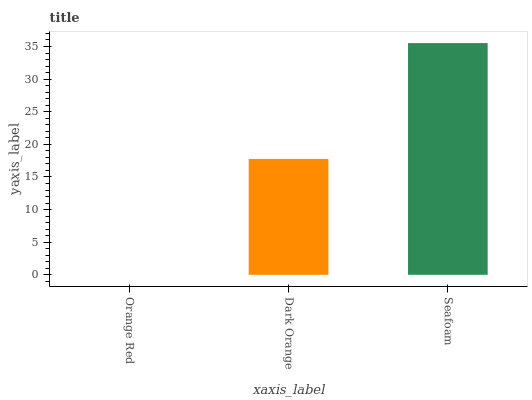Is Dark Orange the minimum?
Answer yes or no. No. Is Dark Orange the maximum?
Answer yes or no. No. Is Dark Orange greater than Orange Red?
Answer yes or no. Yes. Is Orange Red less than Dark Orange?
Answer yes or no. Yes. Is Orange Red greater than Dark Orange?
Answer yes or no. No. Is Dark Orange less than Orange Red?
Answer yes or no. No. Is Dark Orange the high median?
Answer yes or no. Yes. Is Dark Orange the low median?
Answer yes or no. Yes. Is Orange Red the high median?
Answer yes or no. No. Is Seafoam the low median?
Answer yes or no. No. 